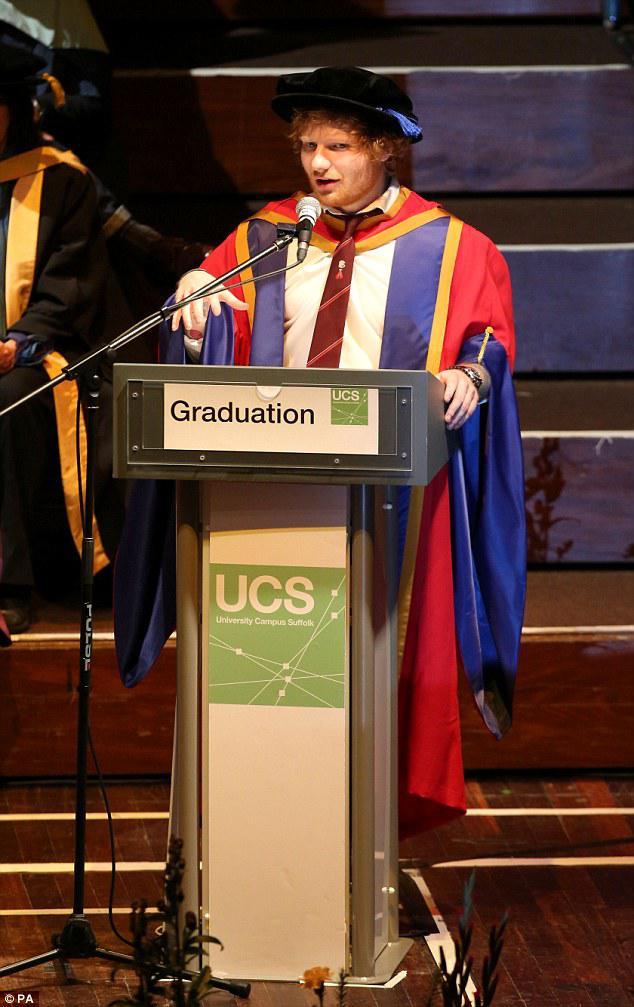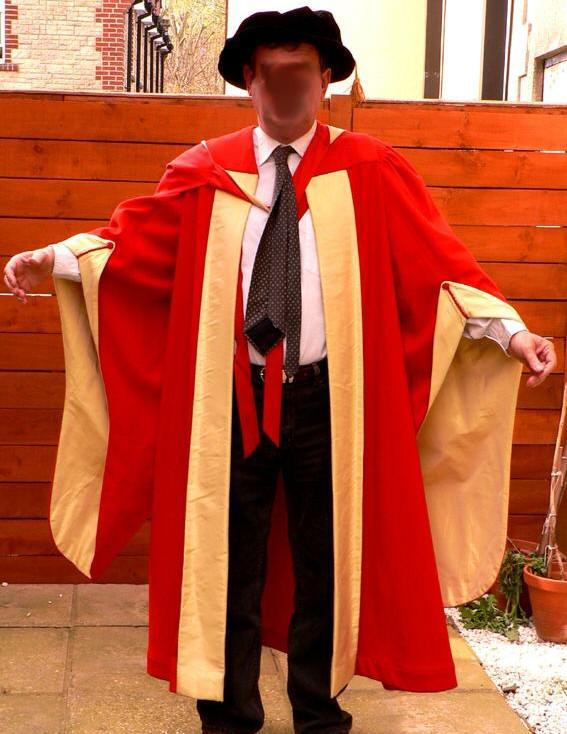The first image is the image on the left, the second image is the image on the right. Analyze the images presented: Is the assertion "One of the graduates is standing at a podium." valid? Answer yes or no. Yes. The first image is the image on the left, the second image is the image on the right. Evaluate the accuracy of this statement regarding the images: "There is a man in the left image standing at a lectern.". Is it true? Answer yes or no. Yes. 